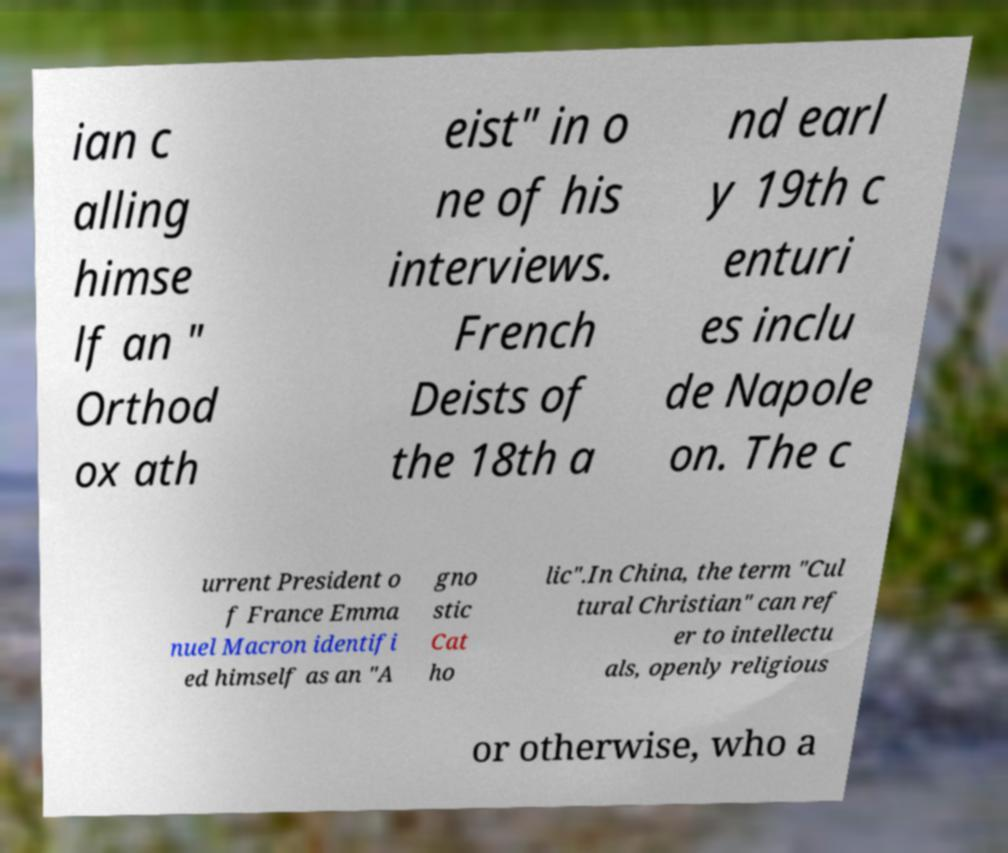What messages or text are displayed in this image? I need them in a readable, typed format. ian c alling himse lf an " Orthod ox ath eist" in o ne of his interviews. French Deists of the 18th a nd earl y 19th c enturi es inclu de Napole on. The c urrent President o f France Emma nuel Macron identifi ed himself as an "A gno stic Cat ho lic".In China, the term "Cul tural Christian" can ref er to intellectu als, openly religious or otherwise, who a 